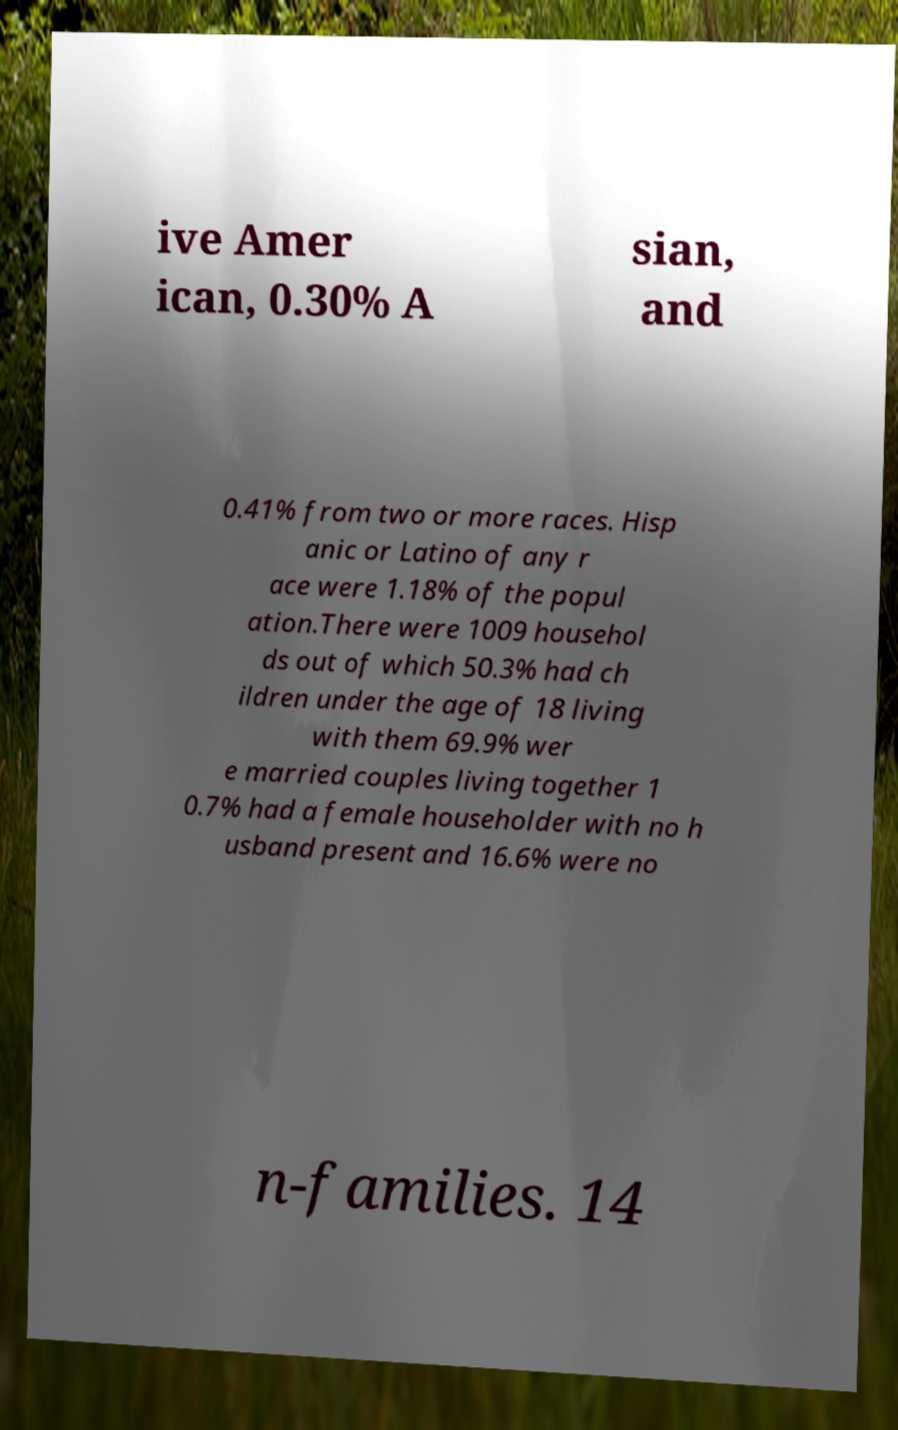I need the written content from this picture converted into text. Can you do that? ive Amer ican, 0.30% A sian, and 0.41% from two or more races. Hisp anic or Latino of any r ace were 1.18% of the popul ation.There were 1009 househol ds out of which 50.3% had ch ildren under the age of 18 living with them 69.9% wer e married couples living together 1 0.7% had a female householder with no h usband present and 16.6% were no n-families. 14 